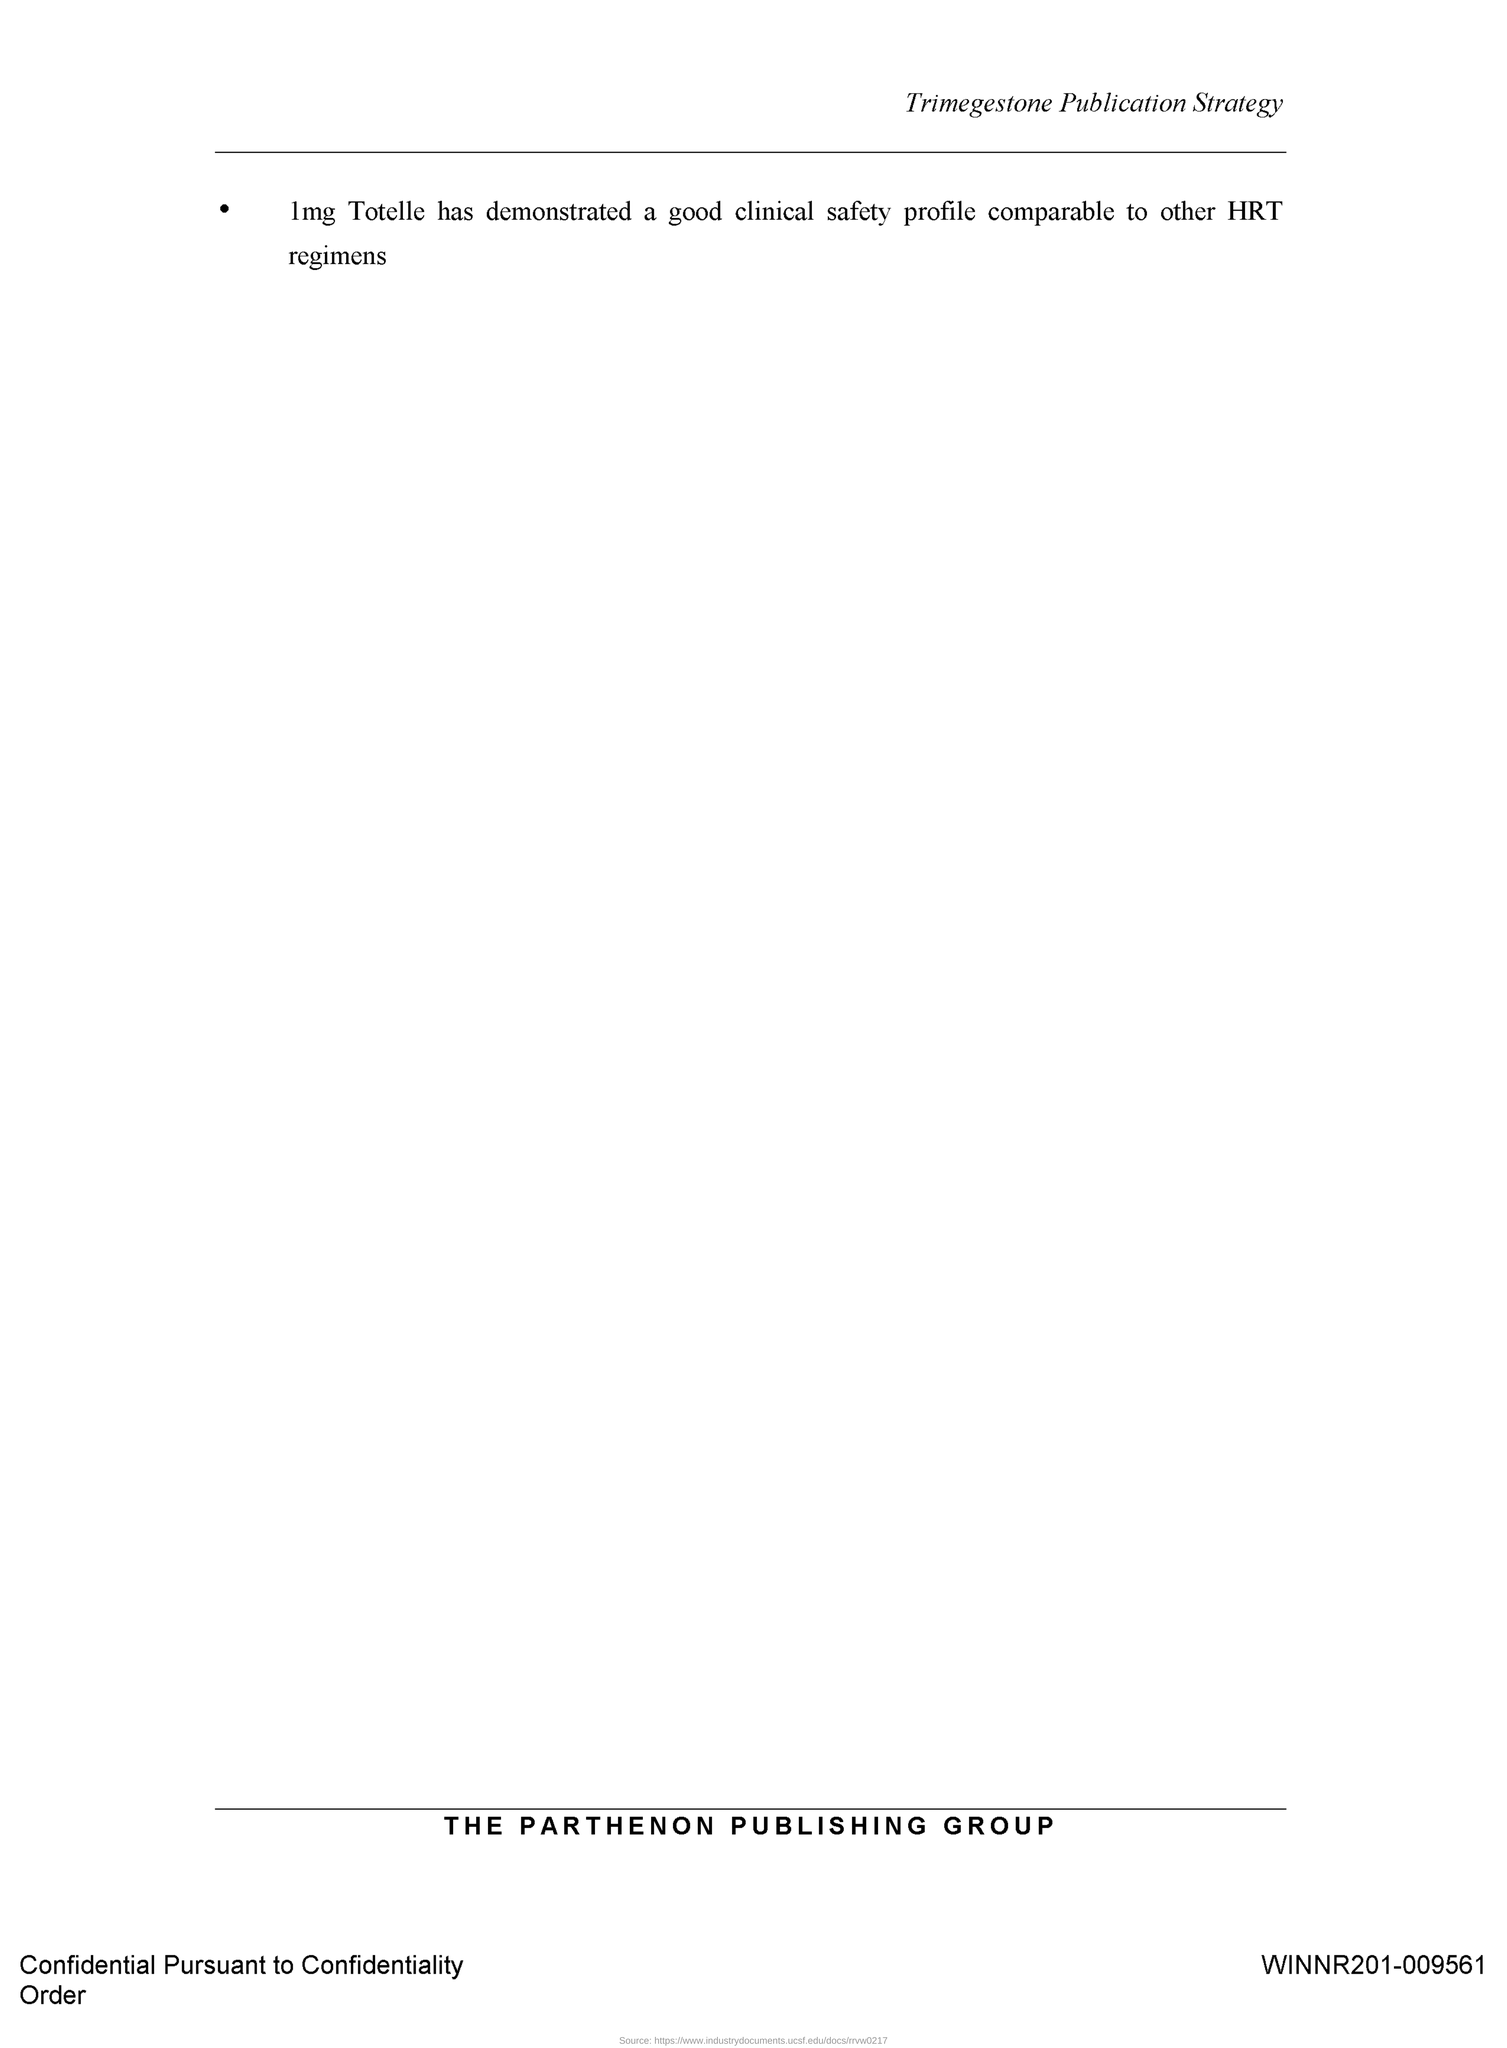Identify some key points in this picture. The Parthenon Publishing Group is mentioned. 